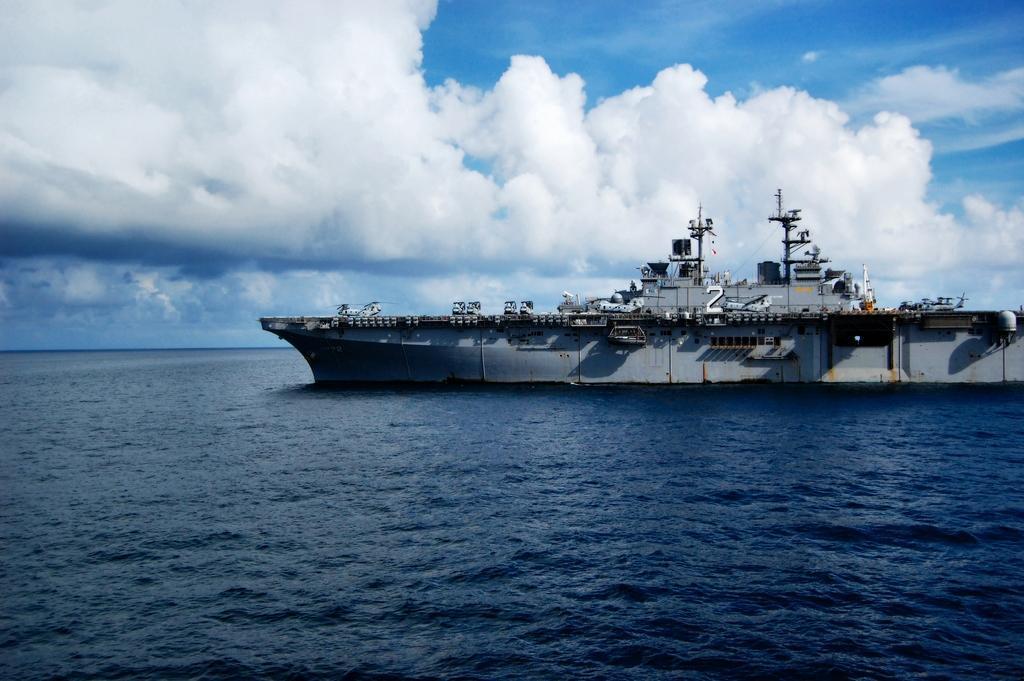Please provide a concise description of this image. In this image, I can see vehicles on a naval ship, which is on the water. In the background, there is the sky. 